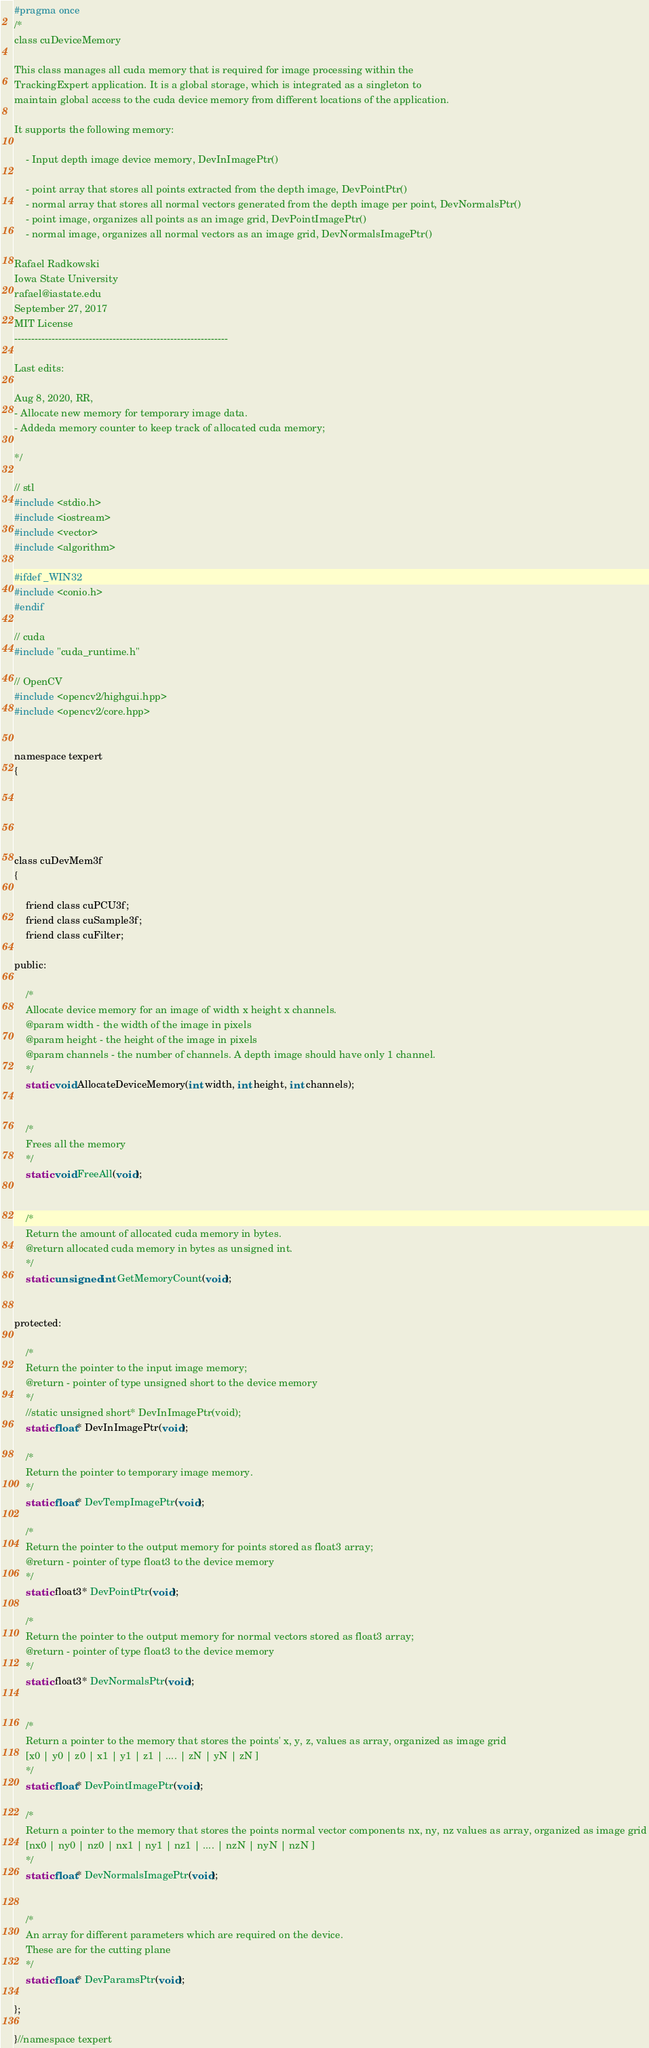Convert code to text. <code><loc_0><loc_0><loc_500><loc_500><_C_>#pragma once
/*
class cuDeviceMemory

This class manages all cuda memory that is required for image processing within the 
TrackingExpert application. It is a global storage, which is integrated as a singleton to
maintain global access to the cuda device memory from different locations of the application.

It supports the following memory:

	- Input depth image device memory, DevInImagePtr()

	- point array that stores all points extracted from the depth image, DevPointPtr()
	- normal array that stores all normal vectors generated from the depth image per point, DevNormalsPtr()
	- point image, organizes all points as an image grid, DevPointImagePtr()
	- normal image, organizes all normal vectors as an image grid, DevNormalsImagePtr()

Rafael Radkowski
Iowa State University
rafael@iastate.edu
September 27, 2017
MIT License
---------------------------------------------------------------

Last edits:

Aug 8, 2020, RR,
- Allocate new memory for temporary image data. 
- Addeda memory counter to keep track of allocated cuda memory;

*/

// stl
#include <stdio.h>
#include <iostream>
#include <vector>
#include <algorithm>

#ifdef _WIN32
#include <conio.h>
#endif

// cuda
#include "cuda_runtime.h"

// OpenCV
#include <opencv2/highgui.hpp>
#include <opencv2/core.hpp>


namespace texpert
{





class cuDevMem3f
{

	friend class cuPCU3f;
	friend class cuSample3f;
	friend class cuFilter;

public:

	/*
	Allocate device memory for an image of width x height x channels.
	@param width - the width of the image in pixels
	@param height - the height of the image in pixels
	@param channels - the number of channels. A depth image should have only 1 channel.
	*/
	static void AllocateDeviceMemory(int width, int height, int channels);


	/*
	Frees all the memory
	*/
	static void FreeAll(void);


	/*
	Return the amount of allocated cuda memory in bytes. 
	@return allocated cuda memory in bytes as unsigned int. 
	*/
	static unsigned int GetMemoryCount(void);


protected:

	/*
	Return the pointer to the input image memory;
	@return - pointer of type unsigned short to the device memory
	*/
	//static unsigned short* DevInImagePtr(void);
	static float* DevInImagePtr(void);

	/*
	Return the pointer to temporary image memory. 
	*/
	static float* DevTempImagePtr(void);

	/*
	Return the pointer to the output memory for points stored as float3 array;
	@return - pointer of type float3 to the device memory
	*/
	static float3* DevPointPtr(void);

	/*
	Return the pointer to the output memory for normal vectors stored as float3 array;
	@return - pointer of type float3 to the device memory
	*/
	static float3* DevNormalsPtr(void);


	/*
	Return a pointer to the memory that stores the points' x, y, z, values as array, organized as image grid
	[x0 | y0 | z0 | x1 | y1 | z1 | .... | zN | yN | zN ]
	*/
	static float* DevPointImagePtr(void);

	/*
	Return a pointer to the memory that stores the points normal vector components nx, ny, nz values as array, organized as image grid
	[nx0 | ny0 | nz0 | nx1 | ny1 | nz1 | .... | nzN | nyN | nzN ]
	*/
	static float* DevNormalsImagePtr(void);


	/*
	An array for different parameters which are required on the device.
	These are for the cutting plane
	*/
	static float* DevParamsPtr(void);

};

}//namespace texpert
</code> 